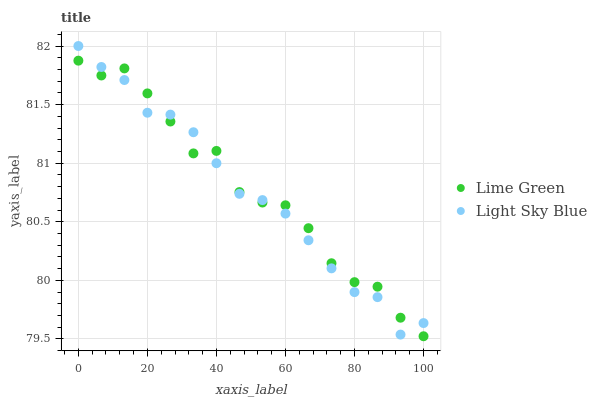Does Light Sky Blue have the minimum area under the curve?
Answer yes or no. Yes. Does Lime Green have the maximum area under the curve?
Answer yes or no. Yes. Does Lime Green have the minimum area under the curve?
Answer yes or no. No. Is Light Sky Blue the smoothest?
Answer yes or no. Yes. Is Lime Green the roughest?
Answer yes or no. Yes. Is Lime Green the smoothest?
Answer yes or no. No. Does Lime Green have the lowest value?
Answer yes or no. Yes. Does Light Sky Blue have the highest value?
Answer yes or no. Yes. Does Lime Green have the highest value?
Answer yes or no. No. Does Light Sky Blue intersect Lime Green?
Answer yes or no. Yes. Is Light Sky Blue less than Lime Green?
Answer yes or no. No. Is Light Sky Blue greater than Lime Green?
Answer yes or no. No. 